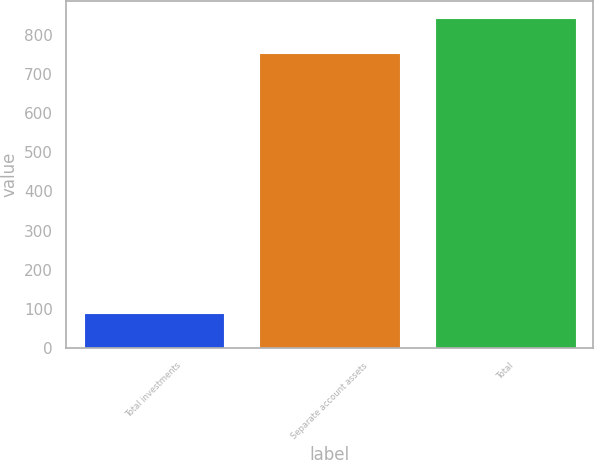Convert chart to OTSL. <chart><loc_0><loc_0><loc_500><loc_500><bar_chart><fcel>Total investments<fcel>Separate account assets<fcel>Total<nl><fcel>89<fcel>755<fcel>844<nl></chart> 